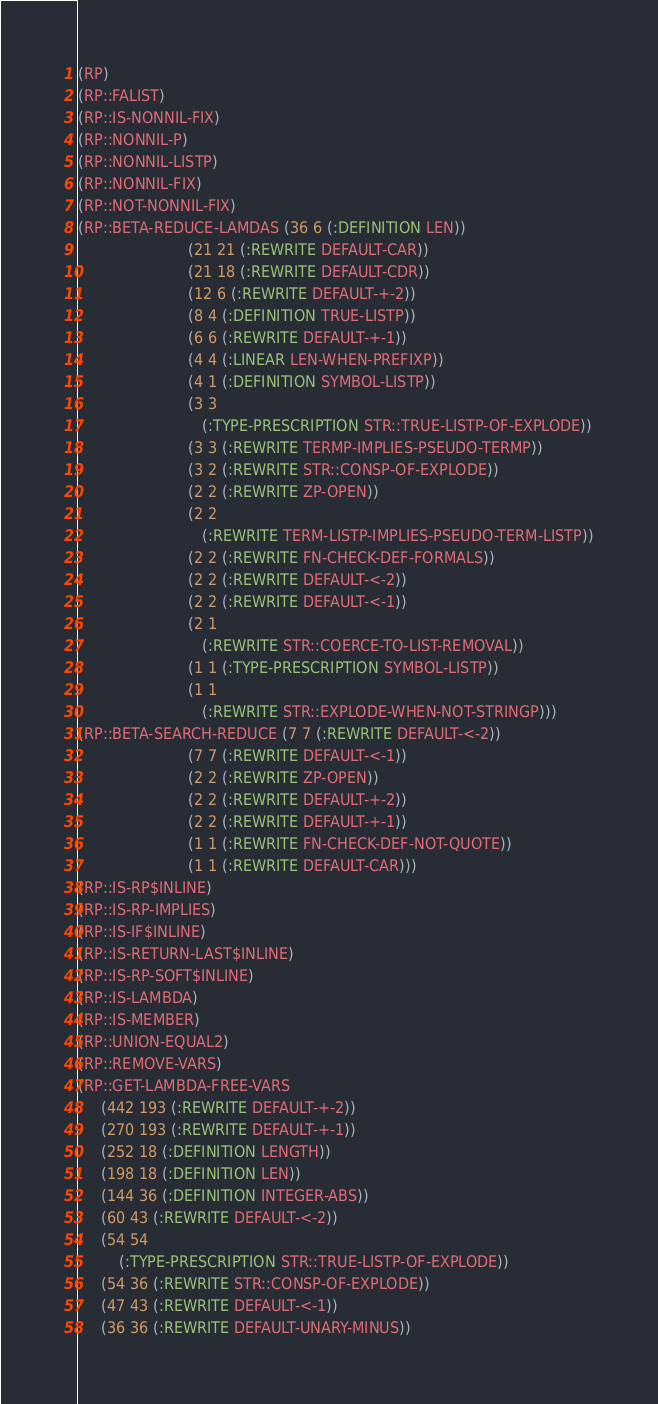<code> <loc_0><loc_0><loc_500><loc_500><_Lisp_>(RP)
(RP::FALIST)
(RP::IS-NONNIL-FIX)
(RP::NONNIL-P)
(RP::NONNIL-LISTP)
(RP::NONNIL-FIX)
(RP::NOT-NONNIL-FIX)
(RP::BETA-REDUCE-LAMDAS (36 6 (:DEFINITION LEN))
                        (21 21 (:REWRITE DEFAULT-CAR))
                        (21 18 (:REWRITE DEFAULT-CDR))
                        (12 6 (:REWRITE DEFAULT-+-2))
                        (8 4 (:DEFINITION TRUE-LISTP))
                        (6 6 (:REWRITE DEFAULT-+-1))
                        (4 4 (:LINEAR LEN-WHEN-PREFIXP))
                        (4 1 (:DEFINITION SYMBOL-LISTP))
                        (3 3
                           (:TYPE-PRESCRIPTION STR::TRUE-LISTP-OF-EXPLODE))
                        (3 3 (:REWRITE TERMP-IMPLIES-PSEUDO-TERMP))
                        (3 2 (:REWRITE STR::CONSP-OF-EXPLODE))
                        (2 2 (:REWRITE ZP-OPEN))
                        (2 2
                           (:REWRITE TERM-LISTP-IMPLIES-PSEUDO-TERM-LISTP))
                        (2 2 (:REWRITE FN-CHECK-DEF-FORMALS))
                        (2 2 (:REWRITE DEFAULT-<-2))
                        (2 2 (:REWRITE DEFAULT-<-1))
                        (2 1
                           (:REWRITE STR::COERCE-TO-LIST-REMOVAL))
                        (1 1 (:TYPE-PRESCRIPTION SYMBOL-LISTP))
                        (1 1
                           (:REWRITE STR::EXPLODE-WHEN-NOT-STRINGP)))
(RP::BETA-SEARCH-REDUCE (7 7 (:REWRITE DEFAULT-<-2))
                        (7 7 (:REWRITE DEFAULT-<-1))
                        (2 2 (:REWRITE ZP-OPEN))
                        (2 2 (:REWRITE DEFAULT-+-2))
                        (2 2 (:REWRITE DEFAULT-+-1))
                        (1 1 (:REWRITE FN-CHECK-DEF-NOT-QUOTE))
                        (1 1 (:REWRITE DEFAULT-CAR)))
(RP::IS-RP$INLINE)
(RP::IS-RP-IMPLIES)
(RP::IS-IF$INLINE)
(RP::IS-RETURN-LAST$INLINE)
(RP::IS-RP-SOFT$INLINE)
(RP::IS-LAMBDA)
(RP::IS-MEMBER)
(RP::UNION-EQUAL2)
(RP::REMOVE-VARS)
(RP::GET-LAMBDA-FREE-VARS
     (442 193 (:REWRITE DEFAULT-+-2))
     (270 193 (:REWRITE DEFAULT-+-1))
     (252 18 (:DEFINITION LENGTH))
     (198 18 (:DEFINITION LEN))
     (144 36 (:DEFINITION INTEGER-ABS))
     (60 43 (:REWRITE DEFAULT-<-2))
     (54 54
         (:TYPE-PRESCRIPTION STR::TRUE-LISTP-OF-EXPLODE))
     (54 36 (:REWRITE STR::CONSP-OF-EXPLODE))
     (47 43 (:REWRITE DEFAULT-<-1))
     (36 36 (:REWRITE DEFAULT-UNARY-MINUS))</code> 